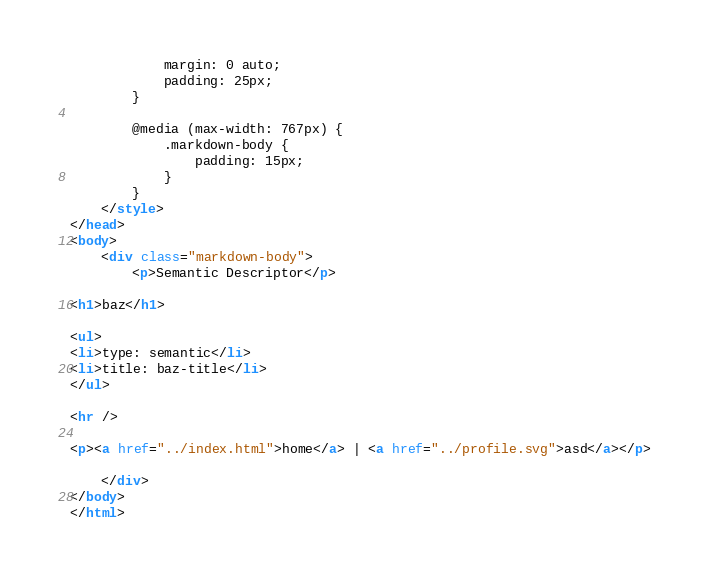<code> <loc_0><loc_0><loc_500><loc_500><_HTML_>            margin: 0 auto;
            padding: 25px;
        }
    
        @media (max-width: 767px) {
            .markdown-body {
                padding: 15px;
            }
        }
    </style>
</head>
<body>
    <div class="markdown-body">
        <p>Semantic Descriptor</p>

<h1>baz</h1>

<ul>
<li>type: semantic</li>
<li>title: baz-title</li>
</ul>

<hr />

<p><a href="../index.html">home</a> | <a href="../profile.svg">asd</a></p>

    </div>
</body>
</html>
</code> 